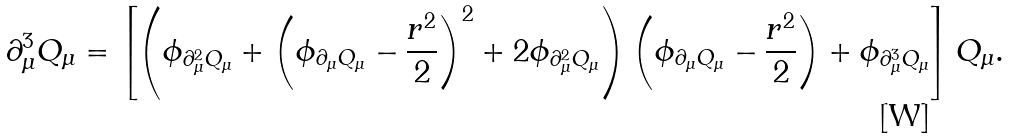Convert formula to latex. <formula><loc_0><loc_0><loc_500><loc_500>\partial ^ { 3 } _ { \mu } Q _ { \mu } = \left [ \left ( \phi _ { \partial ^ { 2 } _ { \mu } Q _ { \mu } } + \left ( \phi _ { \partial _ { \mu } Q _ { \mu } } - \frac { r ^ { 2 } } { 2 } \right ) ^ { 2 } + 2 \phi _ { \partial ^ { 2 } _ { \mu } Q _ { \mu } } \right ) \left ( \phi _ { \partial _ { \mu } Q _ { \mu } } - \frac { r ^ { 2 } } { 2 } \right ) + \phi _ { \partial ^ { 3 } _ { \mu } Q _ { \mu } } \right ] Q _ { \mu } .</formula> 